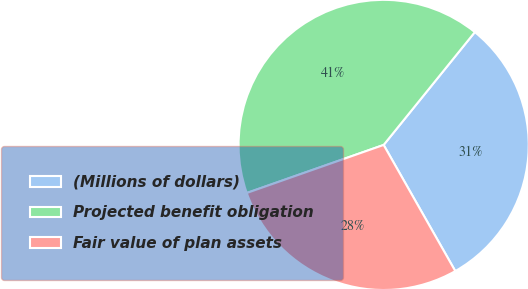Convert chart to OTSL. <chart><loc_0><loc_0><loc_500><loc_500><pie_chart><fcel>(Millions of dollars)<fcel>Projected benefit obligation<fcel>Fair value of plan assets<nl><fcel>30.96%<fcel>41.19%<fcel>27.85%<nl></chart> 